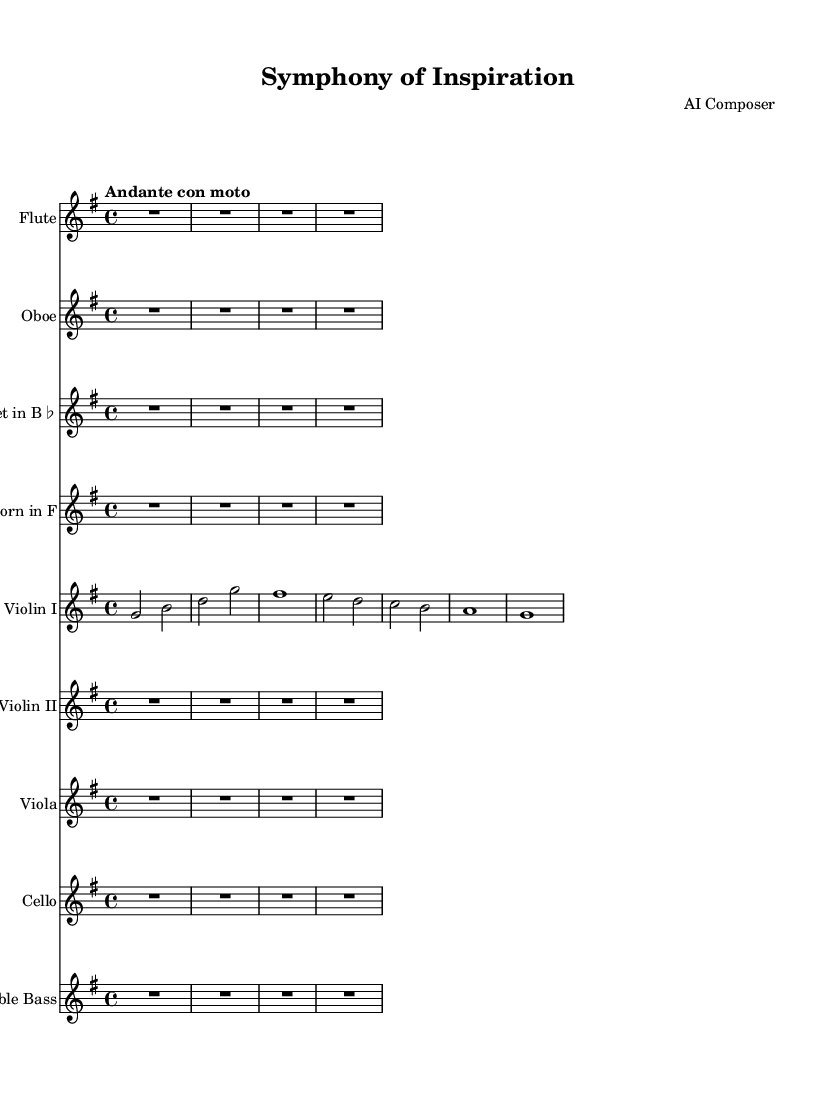What is the key signature of this music? The key signature is G major, which has one sharp (F#). This can be identified by looking at the key signature notation at the beginning of the staff.
Answer: G major What is the time signature of this music? The time signature is four-four, indicated by the "4/4" notation at the beginning of the score, which shows that there are four beats in each measure.
Answer: 4/4 What is the tempo marking of this music? The tempo marking is "Andante con moto," which indicates a moderately slow pace, suggesting a tempo that is relaxed but with a sense of movement. This is found in the tempo indication at the beginning of the score.
Answer: Andante con moto How many instruments are in this symphony? There are eight instruments listed in the score: Flute, Oboe, Clarinet, Horn, Violin I, Violin II, Viola, Cello, and Double Bass. This can be determined by counting the distinct staves shown in the score layout.
Answer: Eight What is the total number of measures in the excerpt from Violin I? There are six measures in the Violin I part. By examining the divisions in the notation, you can count each distinct grouping of beats that constitutes a measure.
Answer: Six Are there any rests in the Flute part? Yes, there is a whole rest indicated in the Flute part for the entire duration of the excerpt. This is clearly shown by the "R1*4" notation which signifies a rest for the given measure.
Answer: Yes Which instruments are using transpositions? The Clarinet and Horn are using transpositions. The Clarinet is indicated as being in B flat, and the Horn is indicated as being in F. These details are noted in the respective staves.
Answer: Clarinet and Horn 